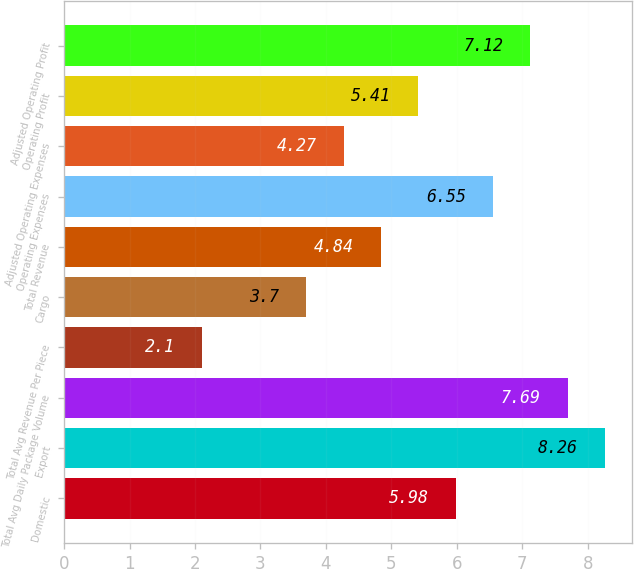<chart> <loc_0><loc_0><loc_500><loc_500><bar_chart><fcel>Domestic<fcel>Export<fcel>Total Avg Daily Package Volume<fcel>Total Avg Revenue Per Piece<fcel>Cargo<fcel>Total Revenue<fcel>Operating Expenses<fcel>Adjusted Operating Expenses<fcel>Operating Profit<fcel>Adjusted Operating Profit<nl><fcel>5.98<fcel>8.26<fcel>7.69<fcel>2.1<fcel>3.7<fcel>4.84<fcel>6.55<fcel>4.27<fcel>5.41<fcel>7.12<nl></chart> 